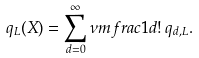Convert formula to latex. <formula><loc_0><loc_0><loc_500><loc_500>q _ { L } ( X ) = \sum _ { d = 0 } ^ { \infty } \nu m f r a c { 1 } { d ! } \, q _ { d , L } .</formula> 